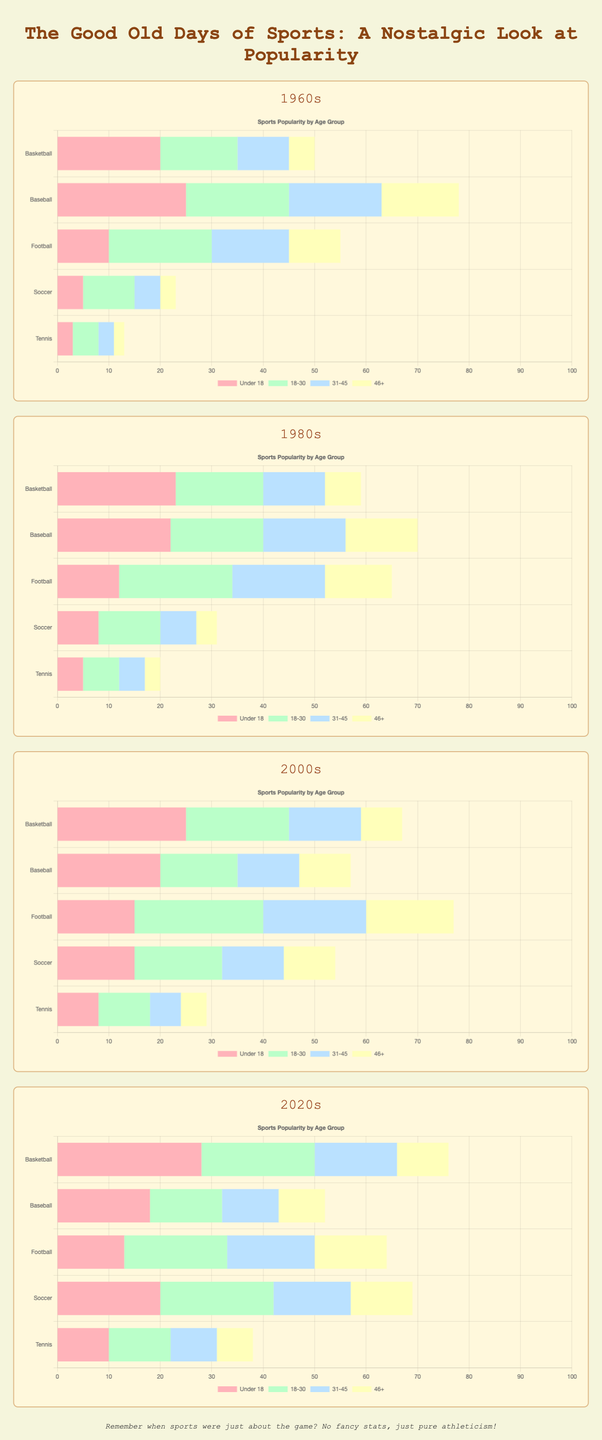Which sport had the most significant increase in popularity across all age groups from the 1960s to the 2020s? To determine the sport with the most significant increase, compare the popularity sums across all age groups in the 1960s and the 2020s for each sport. Basketball had an increase from (20+15+10+5=50) to (28+22+16+10=76), Baseball from (25+20+18+15=78) to (18+14+11+9=52), Football from (10+20+15+10=55) to (13+20+17+14=64), Soccer from (5+10+5+3=23) to (20+22+15+12=69), Tennis from (3+5+3+2=13) to (10+12+9+7=38). The most significant increase is in Basketball.
Answer: Basketball Which decade showed the most balanced distribution of sports popularity among the age groups? Analyze the distribution of percentages for each sport within each age group per decade. The 2020s show a roughly equal distribution across age groups for several sports like Basketball, Soccer, and Tennis. Look at the similarities in heights of bars across age groups for these sports.
Answer: 2020s In the 1980s, which age group contributed the most to the popularity of Football? Examine the heights of the bars for Football in the 1980s. The contributions are Under 18 (12), 18-30 (22), 31-45 (18), 46+ (13). The highest value is for the age group 18-30.
Answer: 18-30 Compare the popularity of Soccer in the 1960s and 2000s for the age group under 18. Which decade had higher popularity? Look at the bar lengths for Soccer under the Under 18 category. In the 1960s, it's 5, and in the 2000s, it's 15. The 2000s had higher popularity.
Answer: 2000s For Tennis, how did the popularity change over the four decades for the age group 46+? Check the heights of the bars for Tennis in the 46+ age group for each decade: 1960s (2), 1980s (3), 2000s (5), 2020s (7). The change is an increase from 2 to 3, then 5, and finally 7.
Answer: Increased Which sport had the least popularity among the 31-45 age group in the 2000s? Identify the shortest bar in the 2000s decade for the 31-45 age group. This is Tennis with a value of 6.
Answer: Tennis In the 1960s, which sport was more popular for the age group 18-30, Baseball or Football? Compare the heights of the bars for Baseball and Football under the 18-30 age group in the 1960s: Baseball (20) and Football (20). Both are equally popular.
Answer: Both Baseball and Football Which decade shows the greatest popularity for Soccer for the Under 18 age group? Compare the bar heights for Soccer under the Under 18 age group across all decades. The 2020s show the highest with 20.
Answer: 2020s In the 2020s, how does the popularity of Basketball for the 18-30 age group compare to Football in the same age group? Look at the bar lengths for the 18-30 age group in the 2020s for Basketball (22) and Football (20). Basketball is more popular.
Answer: Basketball Calculate the total popularity of Baseball across all age groups in the 1980s. Sum the values for Baseball in the 1980s: Under 18 (22), 18-30 (18), 31-45 (16), and 46+ (14). The total is 22+18+16+14=70.
Answer: 70 